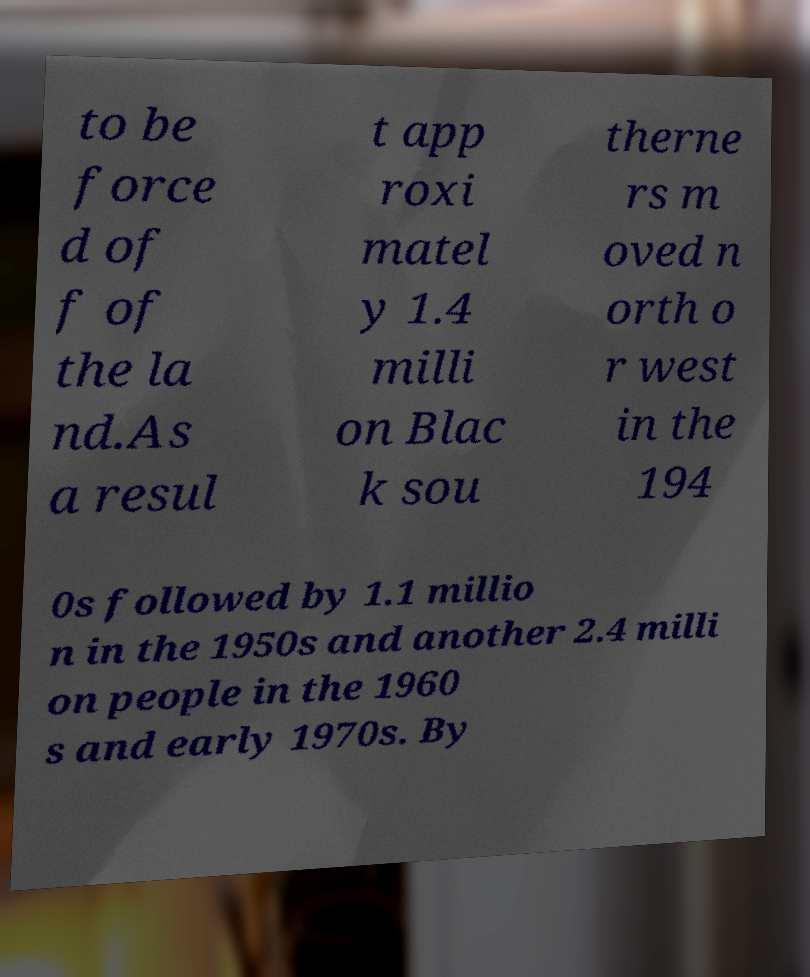I need the written content from this picture converted into text. Can you do that? to be force d of f of the la nd.As a resul t app roxi matel y 1.4 milli on Blac k sou therne rs m oved n orth o r west in the 194 0s followed by 1.1 millio n in the 1950s and another 2.4 milli on people in the 1960 s and early 1970s. By 